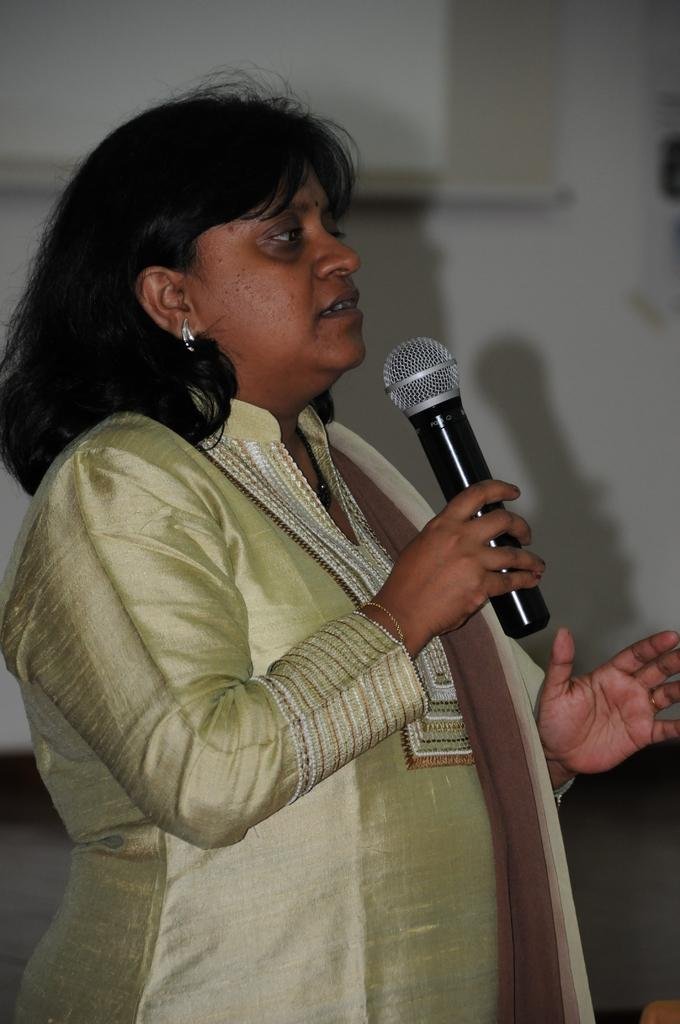What is the main subject of the image? There is a person in the image. What is the person doing in the image? The person is standing in the image. What object is the person holding in her hand? The person is holding a microphone in her hand. What type of rock can be seen in the person's elbow in the image? There is no rock or elbow visible in the image; the person is holding a microphone in her hand. 